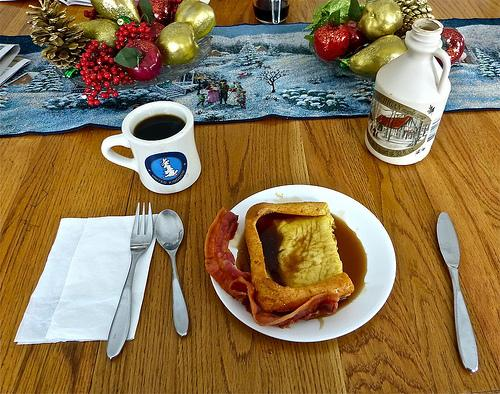Explain the condition and color of the tableware in the image. The silverware is shiny and silver, while the cup and plate are white, complementing the wooden, brown table. Provide a concise and informative description of the image, focusing on the essential elements. On a brown wooden table is a plated breakfast of bacon and french toast, silverware, a white napkin, a bottle, and a white coffee cup. Provide a succinct summary of the beverages present in the image. There is a cup of hot coffee and a bottle or jug placed on the table next to the food. Provide a brief description of the meal setup on the table. There is a breakfast for one person with bacon, french toast, syrup, a cup of coffee, silverware, and a white napkin on a brown wooden table. Create a vivid description of the image, emphasizing the meal and table setup. The tantalizing aroma of french toast topped with syrup fills the room, as bacon sizzles on the plate accompanied by a steaming cup of coffee. This inviting meal awaits on a rustic wooden table adorned with silverware and a white napkin. Describe the scene in the image focusing on the main elements related to a meal. There's a plate full of delicious food, utensils for eating it, and a coffee-filled cup on a wooden table, making a cozy table setting for a meal. Using a formal style, describe the breakfast arrangement and table settings in the image. The table presents an elegant breakfast setting, featuring a serving of bacon, french toast drizzled with syrup, a cup of coffee, silverware, and a pristine white napkin atop a smooth, wooden surface. Using a poetic style, describe the image and bring attention to the color and materials in the scene. Upon a sturdy wooden, brown table lies a delightful morning spread, silver knife and fork, a porcelain white mug brimming with dark coffee, and a bottle storing sweet nectar. Describe the utensils and their position on the table. A knife, a fork, and a teaspoon are placed on the table alongside the breakfast, with the knife and fork having visible handles. In an informal tone, describe the table setting and food items. Yo, we got some bacon, french toast with syrup, coffee in a white mug, and all the silverware we need for a chill breakfast on this cool wooden table. 